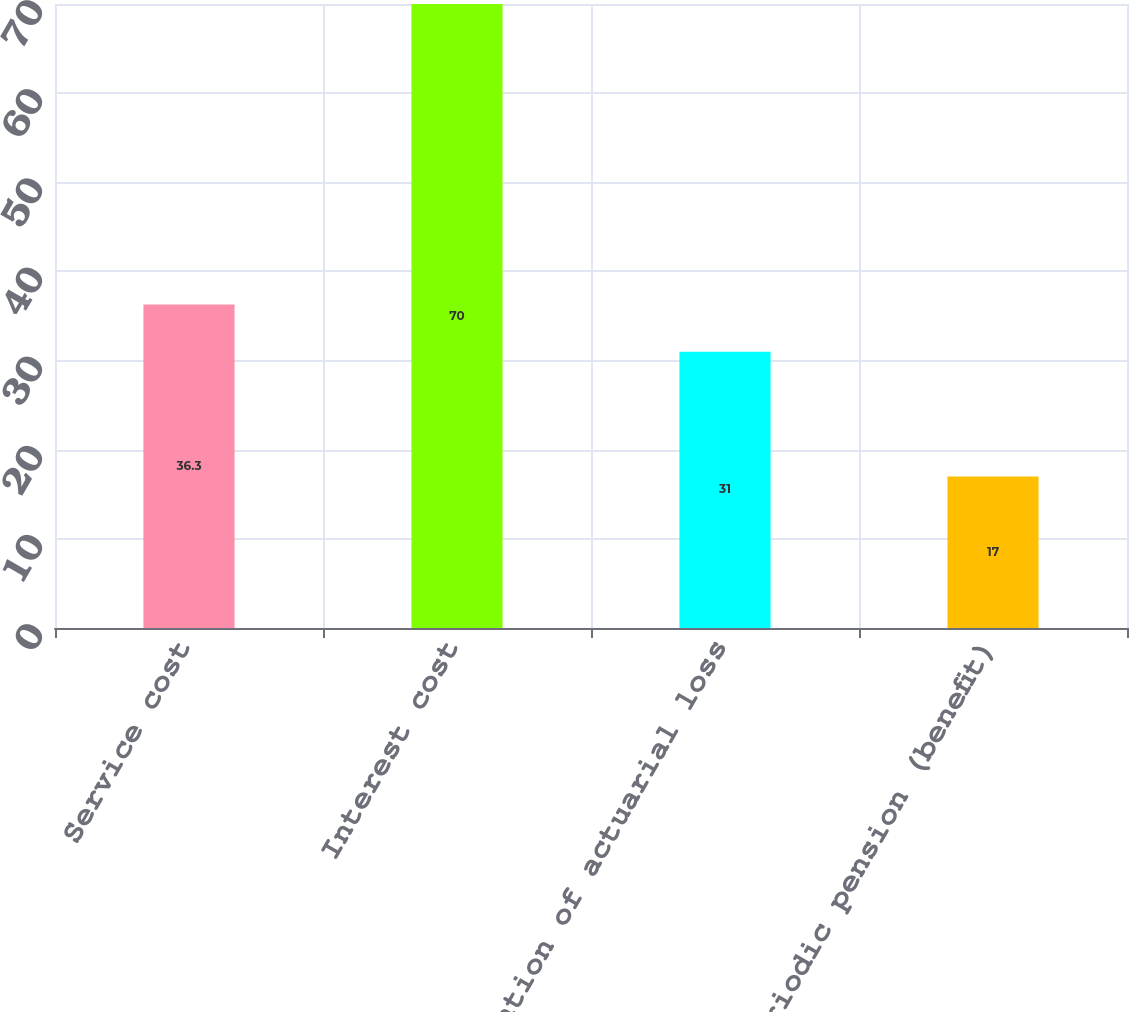Convert chart to OTSL. <chart><loc_0><loc_0><loc_500><loc_500><bar_chart><fcel>Service cost<fcel>Interest cost<fcel>Amortization of actuarial loss<fcel>Net periodic pension (benefit)<nl><fcel>36.3<fcel>70<fcel>31<fcel>17<nl></chart> 